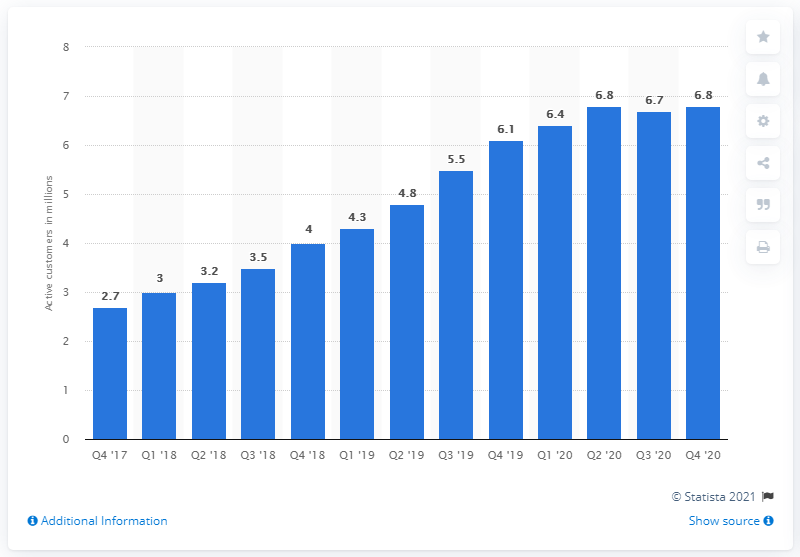Identify some key points in this picture. Jumia had approximately 6.1 customers in the last quarter of 2020. 